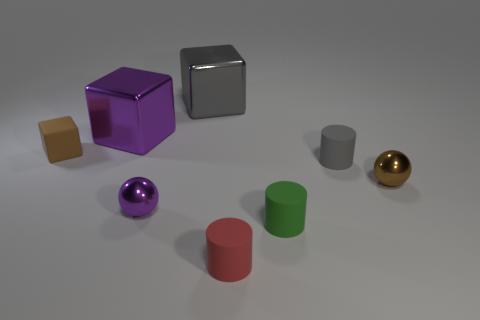There is a purple ball that is the same size as the brown matte thing; what material is it?
Offer a very short reply. Metal. How many other things are there of the same material as the big purple cube?
Keep it short and to the point. 3. Is the number of rubber cylinders that are behind the red object the same as the number of shiny things behind the small purple object?
Offer a terse response. No. What number of blue things are large metallic blocks or tiny objects?
Your response must be concise. 0. Do the rubber block and the shiny ball that is on the left side of the gray rubber cylinder have the same color?
Your answer should be compact. No. What number of other objects are there of the same color as the small block?
Your response must be concise. 1. Are there fewer red matte cubes than tiny green cylinders?
Offer a very short reply. Yes. How many small purple metallic balls are behind the small sphere that is behind the small purple shiny thing to the left of the big gray shiny cube?
Make the answer very short. 0. What size is the gray object that is behind the tiny rubber cube?
Make the answer very short. Large. There is a purple shiny thing that is on the right side of the purple block; is it the same shape as the small brown metallic object?
Provide a succinct answer. Yes. 